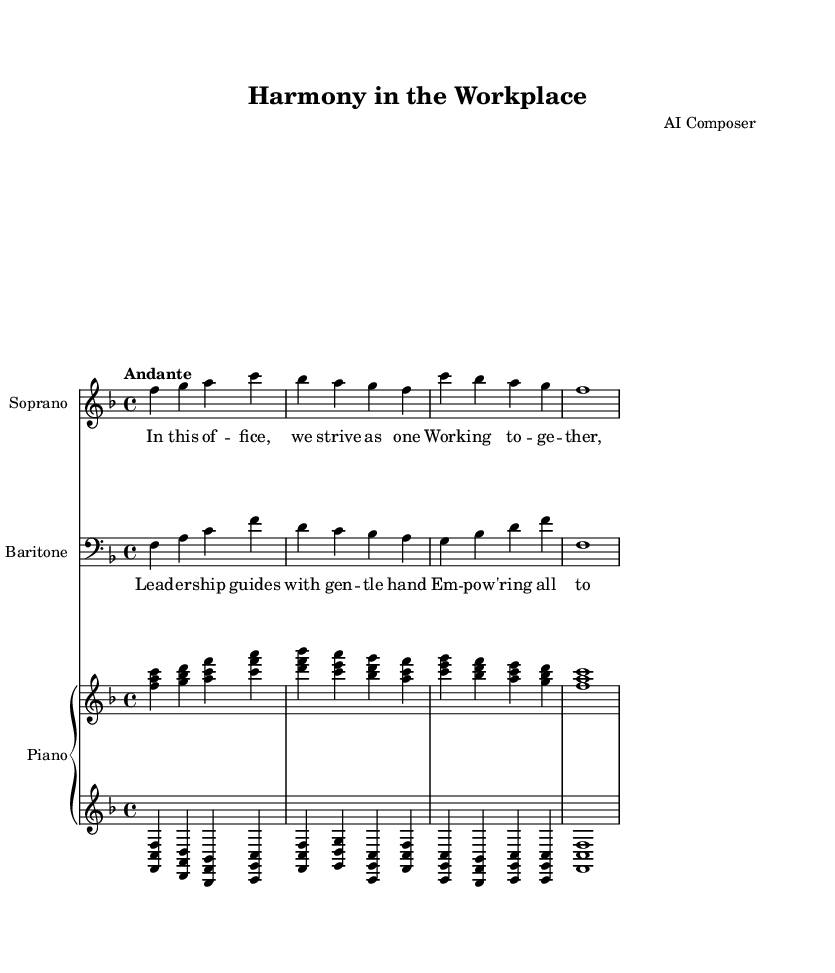What is the key signature of this music? The key signature is F major, which has one flat (B flat). This can be identified by looking at the key signature indicated at the beginning of the staff.
Answer: F major What is the time signature of this music? The time signature is 4/4, which is visible at the beginning of the piece next to the clef. This indicates that there are four beats in each measure and the quarter note gets the beat.
Answer: 4/4 What is the tempo marking of this music? The tempo marking is "Andante," indicating a moderately slow tempo. This is found above the staff at the beginning of the score.
Answer: Andante How many measures are in the soprano part? The soprano part contains four measures, which can be counted by looking at the number of vertical lines on the staff separating the music into measures.
Answer: Four What are the voice types in this duet? The voice types are Soprano and Baritone, indicated at the beginning of each staff labeled accordingly. This reflects the standard pairing in opera duets.
Answer: Soprano and Baritone What is the primary theme of the lyrics? The primary theme of the lyrics emphasizes working together and understanding within a workplace context, as suggested by the text provided in the lyrics sections.
Answer: Harmony in the workplace 